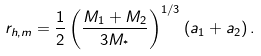Convert formula to latex. <formula><loc_0><loc_0><loc_500><loc_500>r _ { h , m } = \frac { 1 } { 2 } \left ( \frac { M _ { 1 } + M _ { 2 } } { 3 M _ { ^ { * } } } \right ) ^ { 1 / 3 } \left ( a _ { 1 } + a _ { 2 } \right ) .</formula> 